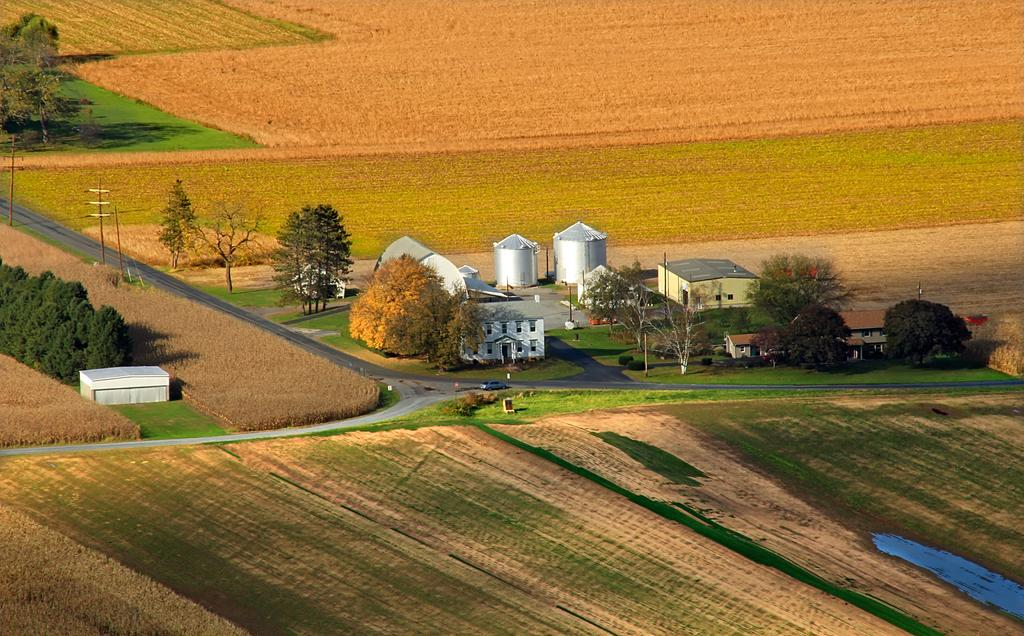What type of environment is shown in the image? The image depicts an open land. What natural elements can be seen in the image? There are trees and grass on the land. Are there any man-made structures visible in the image? Yes, there are buildings visible in the image. What type of haircut is the tree on the left side of the image getting? There is no haircut or tree getting a haircut in the image; it depicts an open land with trees and buildings. Are there any masks visible on the grass in the image? There are no masks present in the image; it shows an open land with trees, grass, and buildings. 